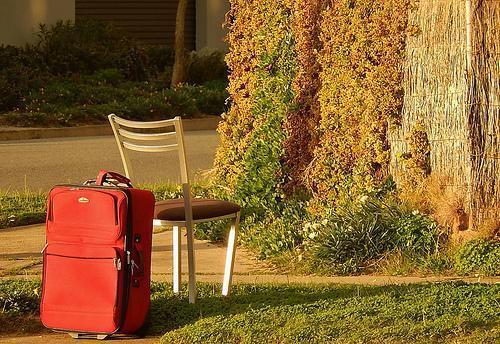How many chairs are there?
Give a very brief answer. 1. How many suitcases are in the picture?
Give a very brief answer. 1. How many people are in this picture?
Give a very brief answer. 0. 